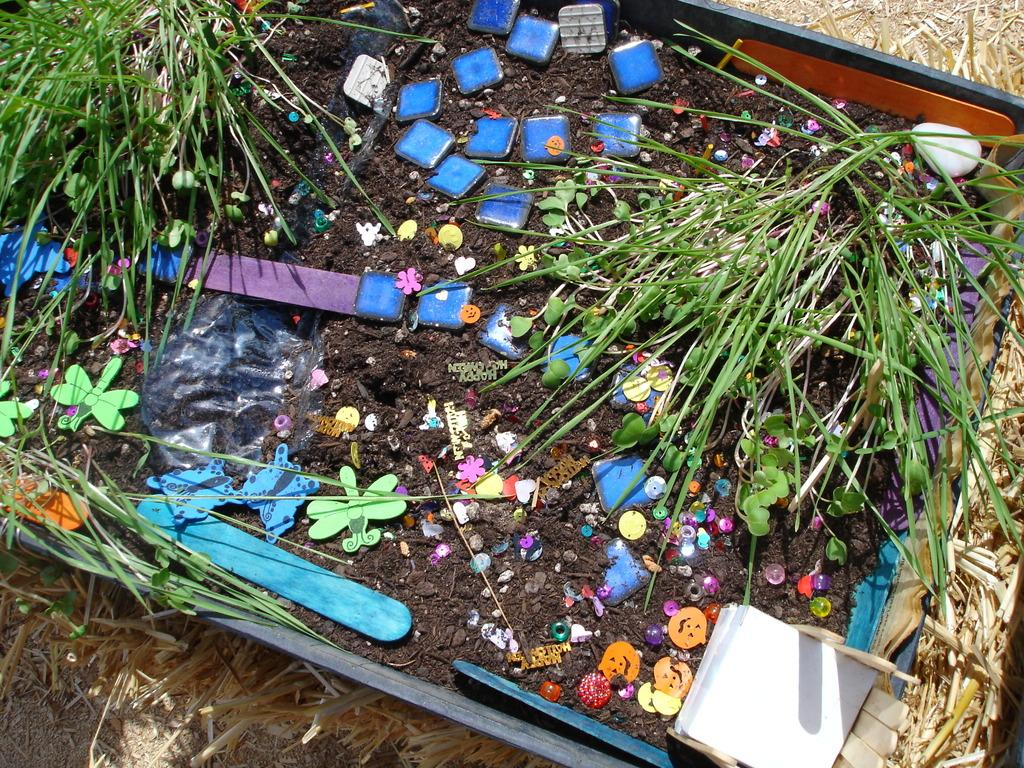What type of surface can be seen in the image? There is grass and mud in the image. What objects are present in the image? There are wooden sticks in a container and dried grass beside the container in the image. Can you describe the container in the image? The container is holding wooden sticks. What is the name of the person who created the dried grass in the image? There is no information about the creator of the dried grass in the image. 